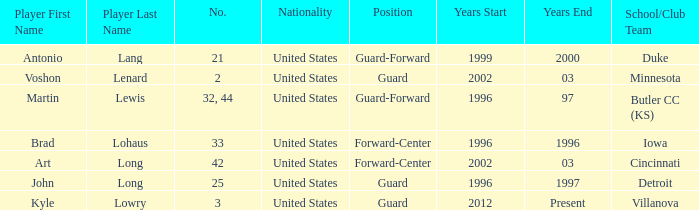Who is the player that wears number 42? Art Long. 